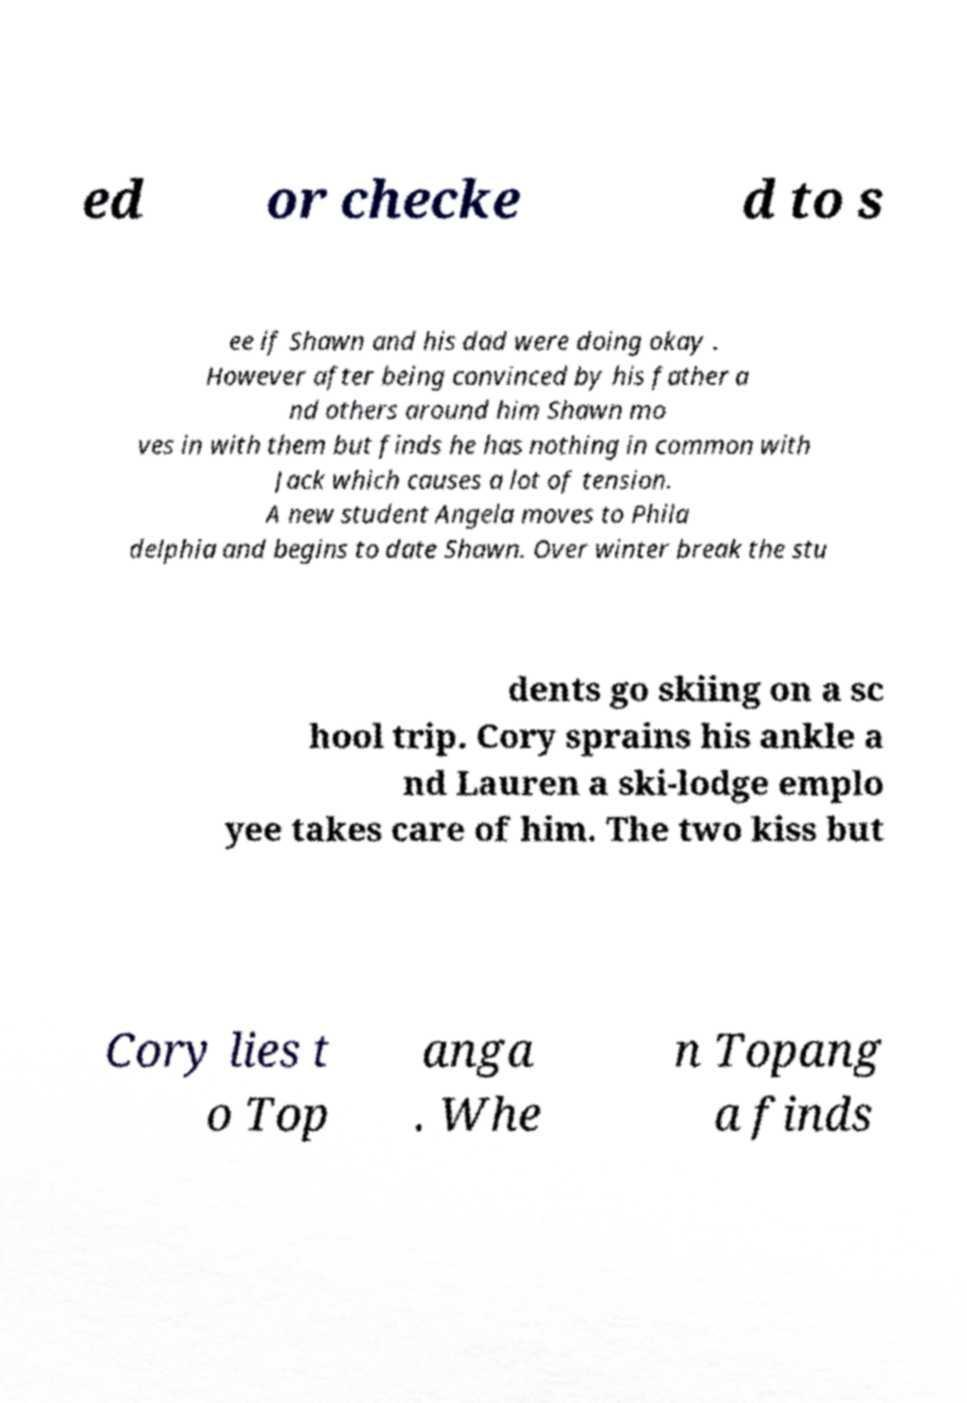Could you assist in decoding the text presented in this image and type it out clearly? ed or checke d to s ee if Shawn and his dad were doing okay . However after being convinced by his father a nd others around him Shawn mo ves in with them but finds he has nothing in common with Jack which causes a lot of tension. A new student Angela moves to Phila delphia and begins to date Shawn. Over winter break the stu dents go skiing on a sc hool trip. Cory sprains his ankle a nd Lauren a ski-lodge emplo yee takes care of him. The two kiss but Cory lies t o Top anga . Whe n Topang a finds 